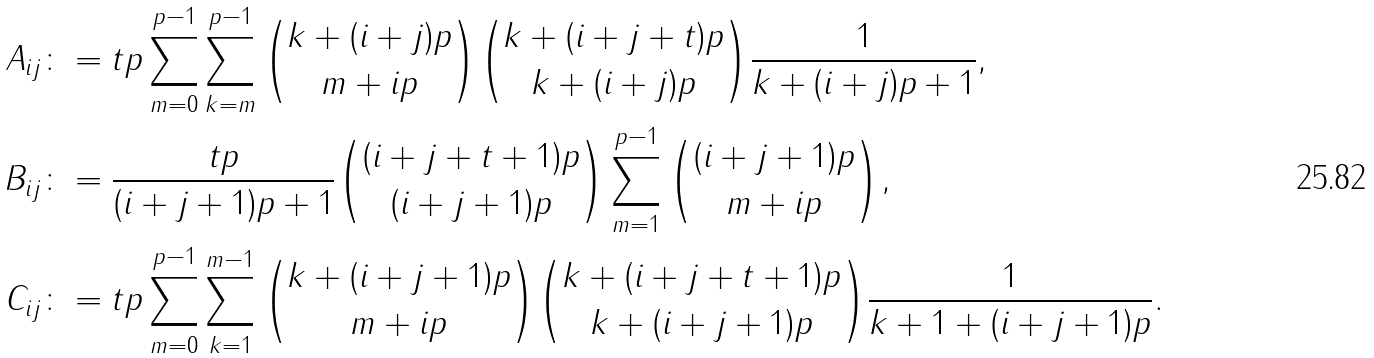<formula> <loc_0><loc_0><loc_500><loc_500>A _ { i j } & \colon = t p \sum _ { m = 0 } ^ { p - 1 } \sum _ { k = m } ^ { p - 1 } \binom { k + ( i + j ) p } { m + i p } \binom { k + ( i + j + t ) p } { k + ( i + j ) p } \frac { 1 } { k + ( i + j ) p + 1 } , \\ B _ { i j } & \colon = \frac { t p } { ( i + j + 1 ) p + 1 } \binom { ( i + j + t + 1 ) p } { ( i + j + 1 ) p } \sum _ { m = 1 } ^ { p - 1 } \binom { ( i + j + 1 ) p } { m + i p } , \\ C _ { i j } & \colon = t p \sum _ { m = 0 } ^ { p - 1 } \sum _ { k = 1 } ^ { m - 1 } \binom { k + ( i + j + 1 ) p } { m + i p } \binom { k + ( i + j + t + 1 ) p } { k + ( i + j + 1 ) p } \frac { 1 } { k + 1 + ( i + j + 1 ) p } .</formula> 